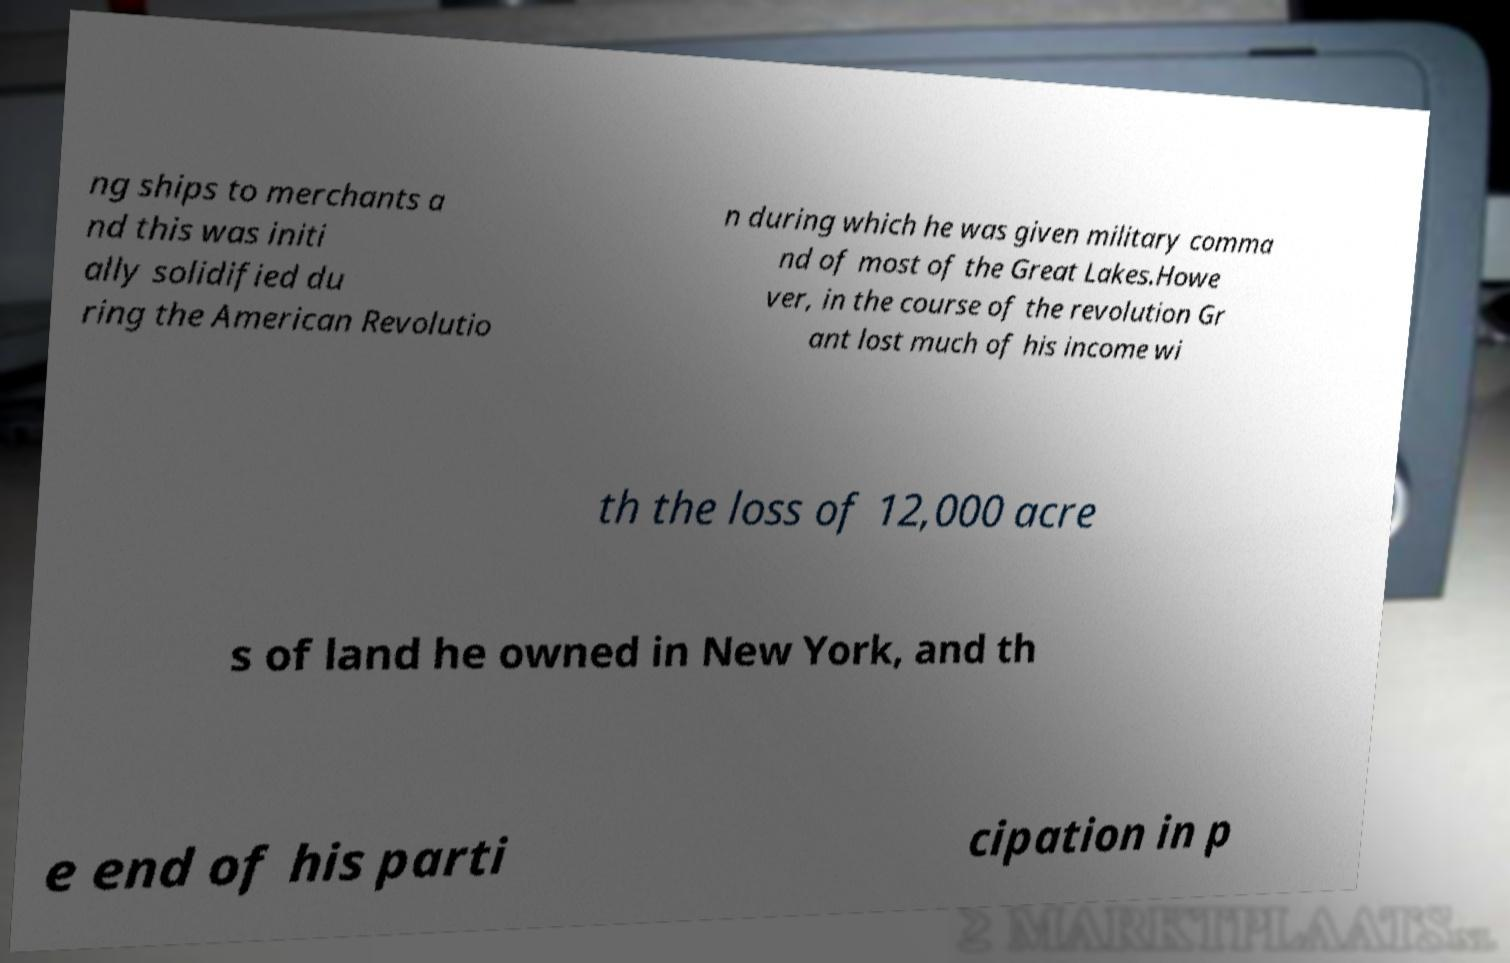I need the written content from this picture converted into text. Can you do that? ng ships to merchants a nd this was initi ally solidified du ring the American Revolutio n during which he was given military comma nd of most of the Great Lakes.Howe ver, in the course of the revolution Gr ant lost much of his income wi th the loss of 12,000 acre s of land he owned in New York, and th e end of his parti cipation in p 